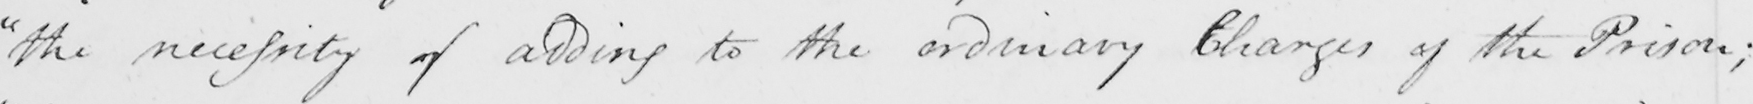Transcribe the text shown in this historical manuscript line. " the necessity of adding to the ordinary Charges of the Prison ; 